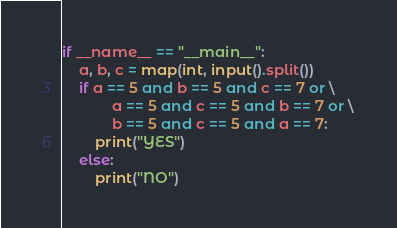<code> <loc_0><loc_0><loc_500><loc_500><_Python_>

if __name__ == "__main__":
    a, b, c = map(int, input().split())
    if a == 5 and b == 5 and c == 7 or \
            a == 5 and c == 5 and b == 7 or \
            b == 5 and c == 5 and a == 7:
        print("YES")
    else:
        print("NO")</code> 